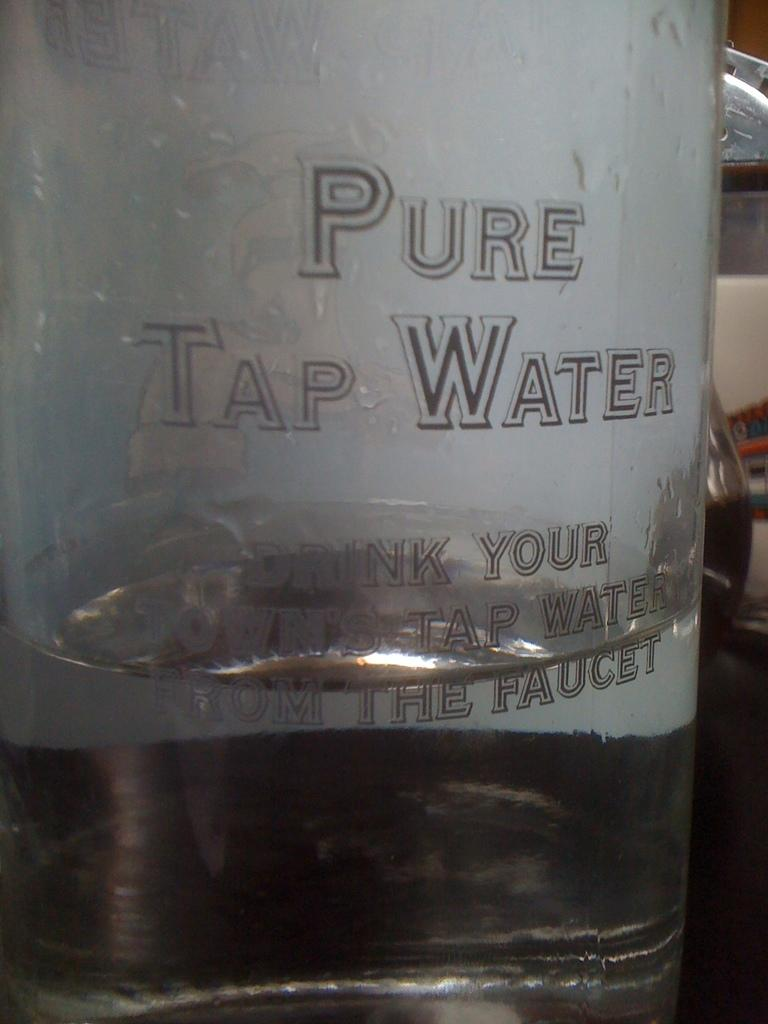<image>
Share a concise interpretation of the image provided. A bottle that says Pure Tap Water advertising drinking your own tap water. 